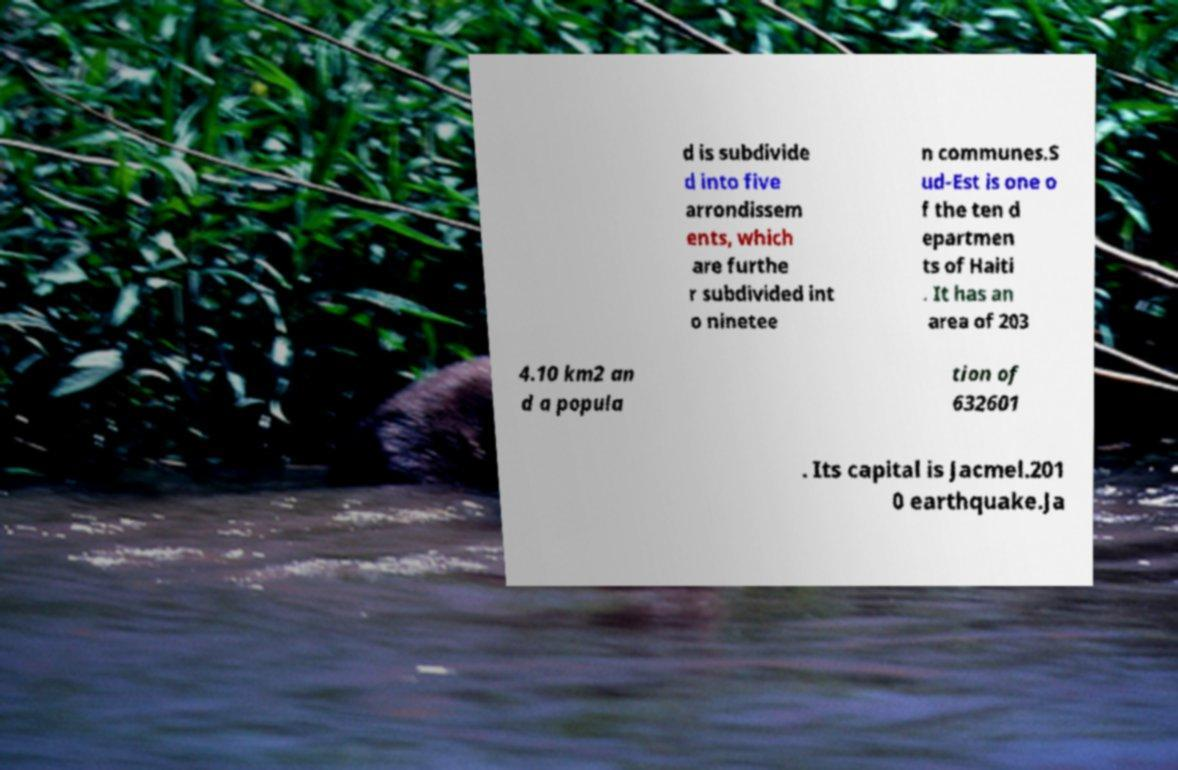There's text embedded in this image that I need extracted. Can you transcribe it verbatim? d is subdivide d into five arrondissem ents, which are furthe r subdivided int o ninetee n communes.S ud-Est is one o f the ten d epartmen ts of Haiti . It has an area of 203 4.10 km2 an d a popula tion of 632601 . Its capital is Jacmel.201 0 earthquake.Ja 